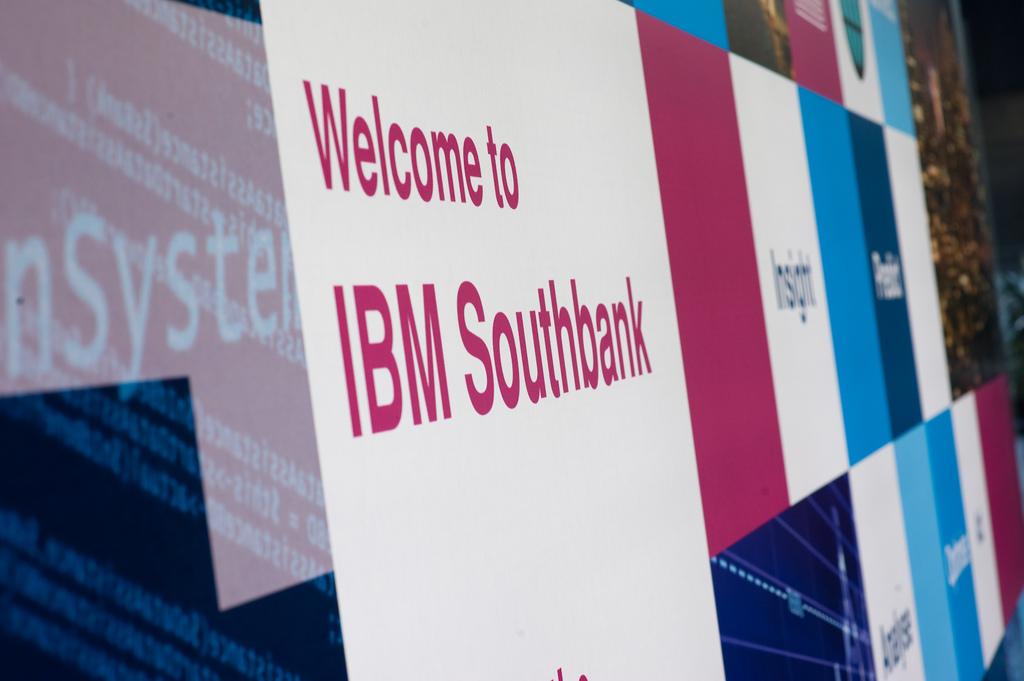Welcome to what?
Your response must be concise. Ibm southbank. What company is being promoted?
Keep it short and to the point. Ibm southbank. 